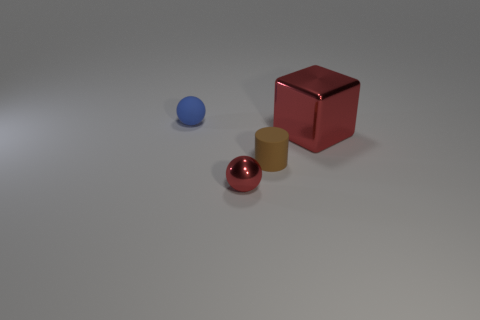Add 4 small yellow objects. How many objects exist? 8 Subtract 0 yellow spheres. How many objects are left? 4 Subtract all cylinders. How many objects are left? 3 Subtract all brown cylinders. Subtract all small red shiny objects. How many objects are left? 2 Add 1 small red metallic objects. How many small red metallic objects are left? 2 Add 2 small red balls. How many small red balls exist? 3 